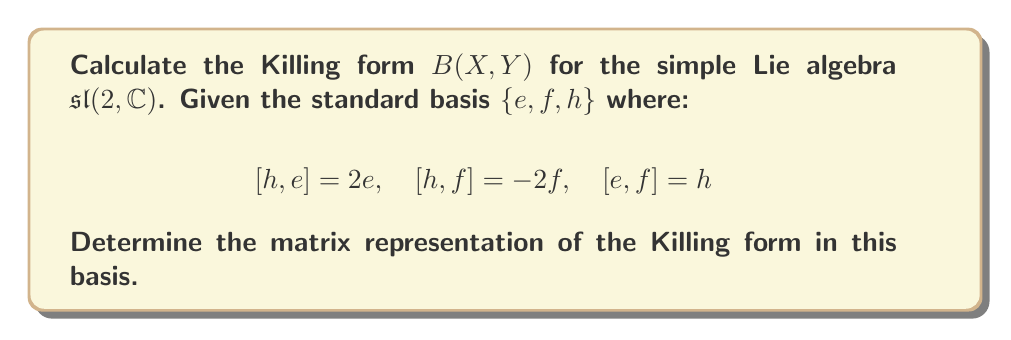Teach me how to tackle this problem. To calculate the Killing form for $\mathfrak{sl}(2,\mathbb{C})$, we follow these steps:

1) The Killing form is defined as $B(X,Y) = \text{tr}(\text{ad}_X \circ \text{ad}_Y)$, where $\text{ad}_X(Z) = [X,Z]$.

2) We need to compute $\text{ad}_X$ for each basis element:

   For $\text{ad}_h$: $\text{ad}_h(e) = 2e, \text{ad}_h(f) = -2f, \text{ad}_h(h) = 0$
   For $\text{ad}_e$: $\text{ad}_e(e) = 0, \text{ad}_e(f) = h, \text{ad}_e(h) = -2e$
   For $\text{ad}_f$: $\text{ad}_f(e) = -h, \text{ad}_f(f) = 0, \text{ad}_f(h) = 2f$

3) Now, we can represent these as matrices in the given basis:

   $$\text{ad}_h = \begin{pmatrix} 2 & 0 & 0 \\ 0 & -2 & 0 \\ 0 & 0 & 0 \end{pmatrix}, \quad
   \text{ad}_e = \begin{pmatrix} 0 & 0 & -2 \\ 0 & 0 & 0 \\ 1 & 0 & 0 \end{pmatrix}, \quad
   \text{ad}_f = \begin{pmatrix} 0 & 0 & 0 \\ 0 & 0 & 2 \\ -1 & 0 & 0 \end{pmatrix}$$

4) We can now compute $B(X,Y)$ for all pairs of basis elements:

   $B(h,h) = \text{tr}(\text{ad}_h \circ \text{ad}_h) = 2^2 + (-2)^2 + 0^2 = 8$
   $B(e,f) = \text{tr}(\text{ad}_e \circ \text{ad}_f) = 0 + 0 + (-2)(2) = -4$
   $B(f,e) = \text{tr}(\text{ad}_f \circ \text{ad}_e) = 0 + 0 + (2)(-2) = -4$
   $B(h,e) = B(e,h) = \text{tr}(\text{ad}_h \circ \text{ad}_e) = 0$
   $B(h,f) = B(f,h) = \text{tr}(\text{ad}_h \circ \text{ad}_f) = 0$
   $B(e,e) = B(f,f) = 0$

5) Therefore, the matrix representation of the Killing form in the basis $\{h,e,f\}$ is:

   $$B = \begin{pmatrix} 8 & 0 & 0 \\ 0 & 0 & -4 \\ 0 & -4 & 0 \end{pmatrix}$$
Answer: The Killing form for $\mathfrak{sl}(2,\mathbb{C})$ in the basis $\{h,e,f\}$ is represented by the matrix:

$$B = \begin{pmatrix} 8 & 0 & 0 \\ 0 & 0 & -4 \\ 0 & -4 & 0 \end{pmatrix}$$ 